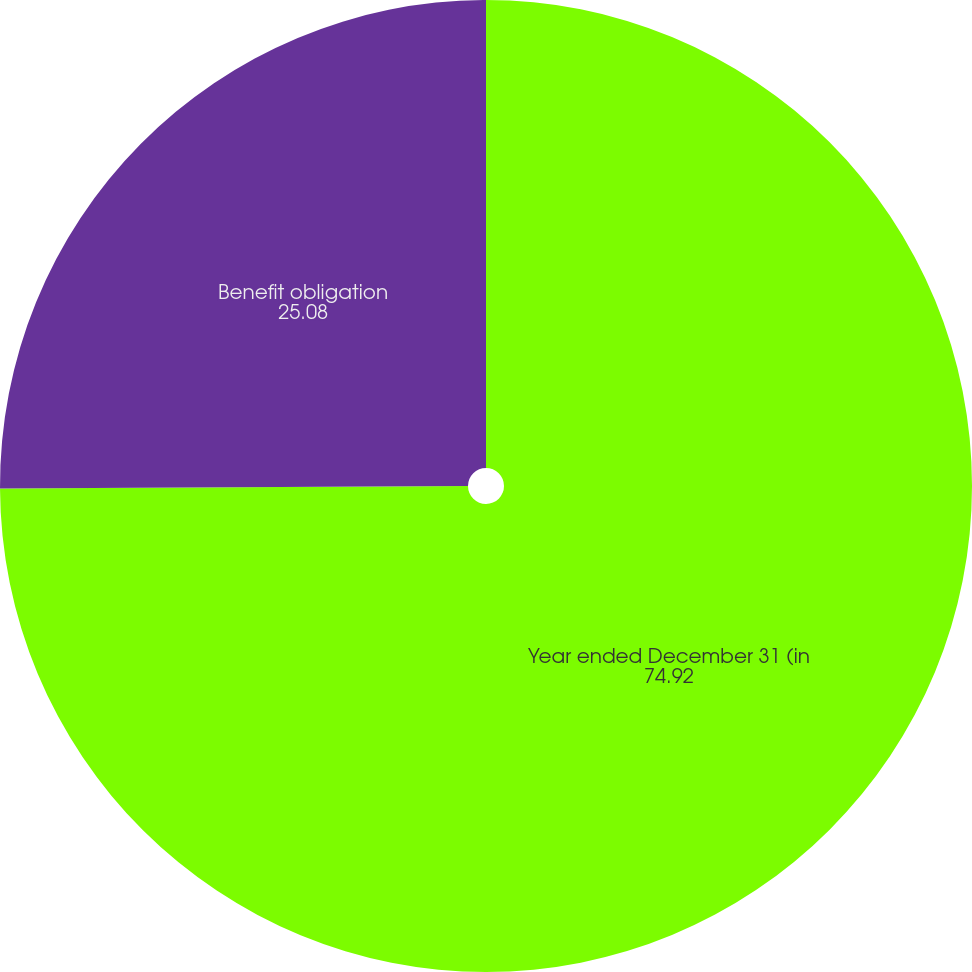<chart> <loc_0><loc_0><loc_500><loc_500><pie_chart><fcel>Year ended December 31 (in<fcel>Benefit obligation<nl><fcel>74.92%<fcel>25.08%<nl></chart> 